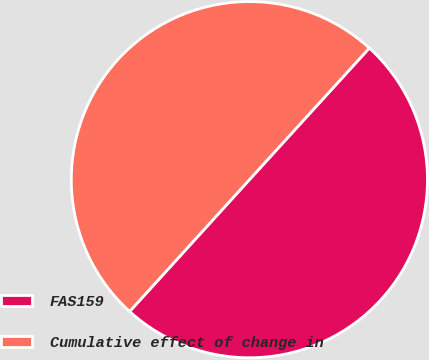Convert chart. <chart><loc_0><loc_0><loc_500><loc_500><pie_chart><fcel>FAS159<fcel>Cumulative effect of change in<nl><fcel>49.98%<fcel>50.02%<nl></chart> 